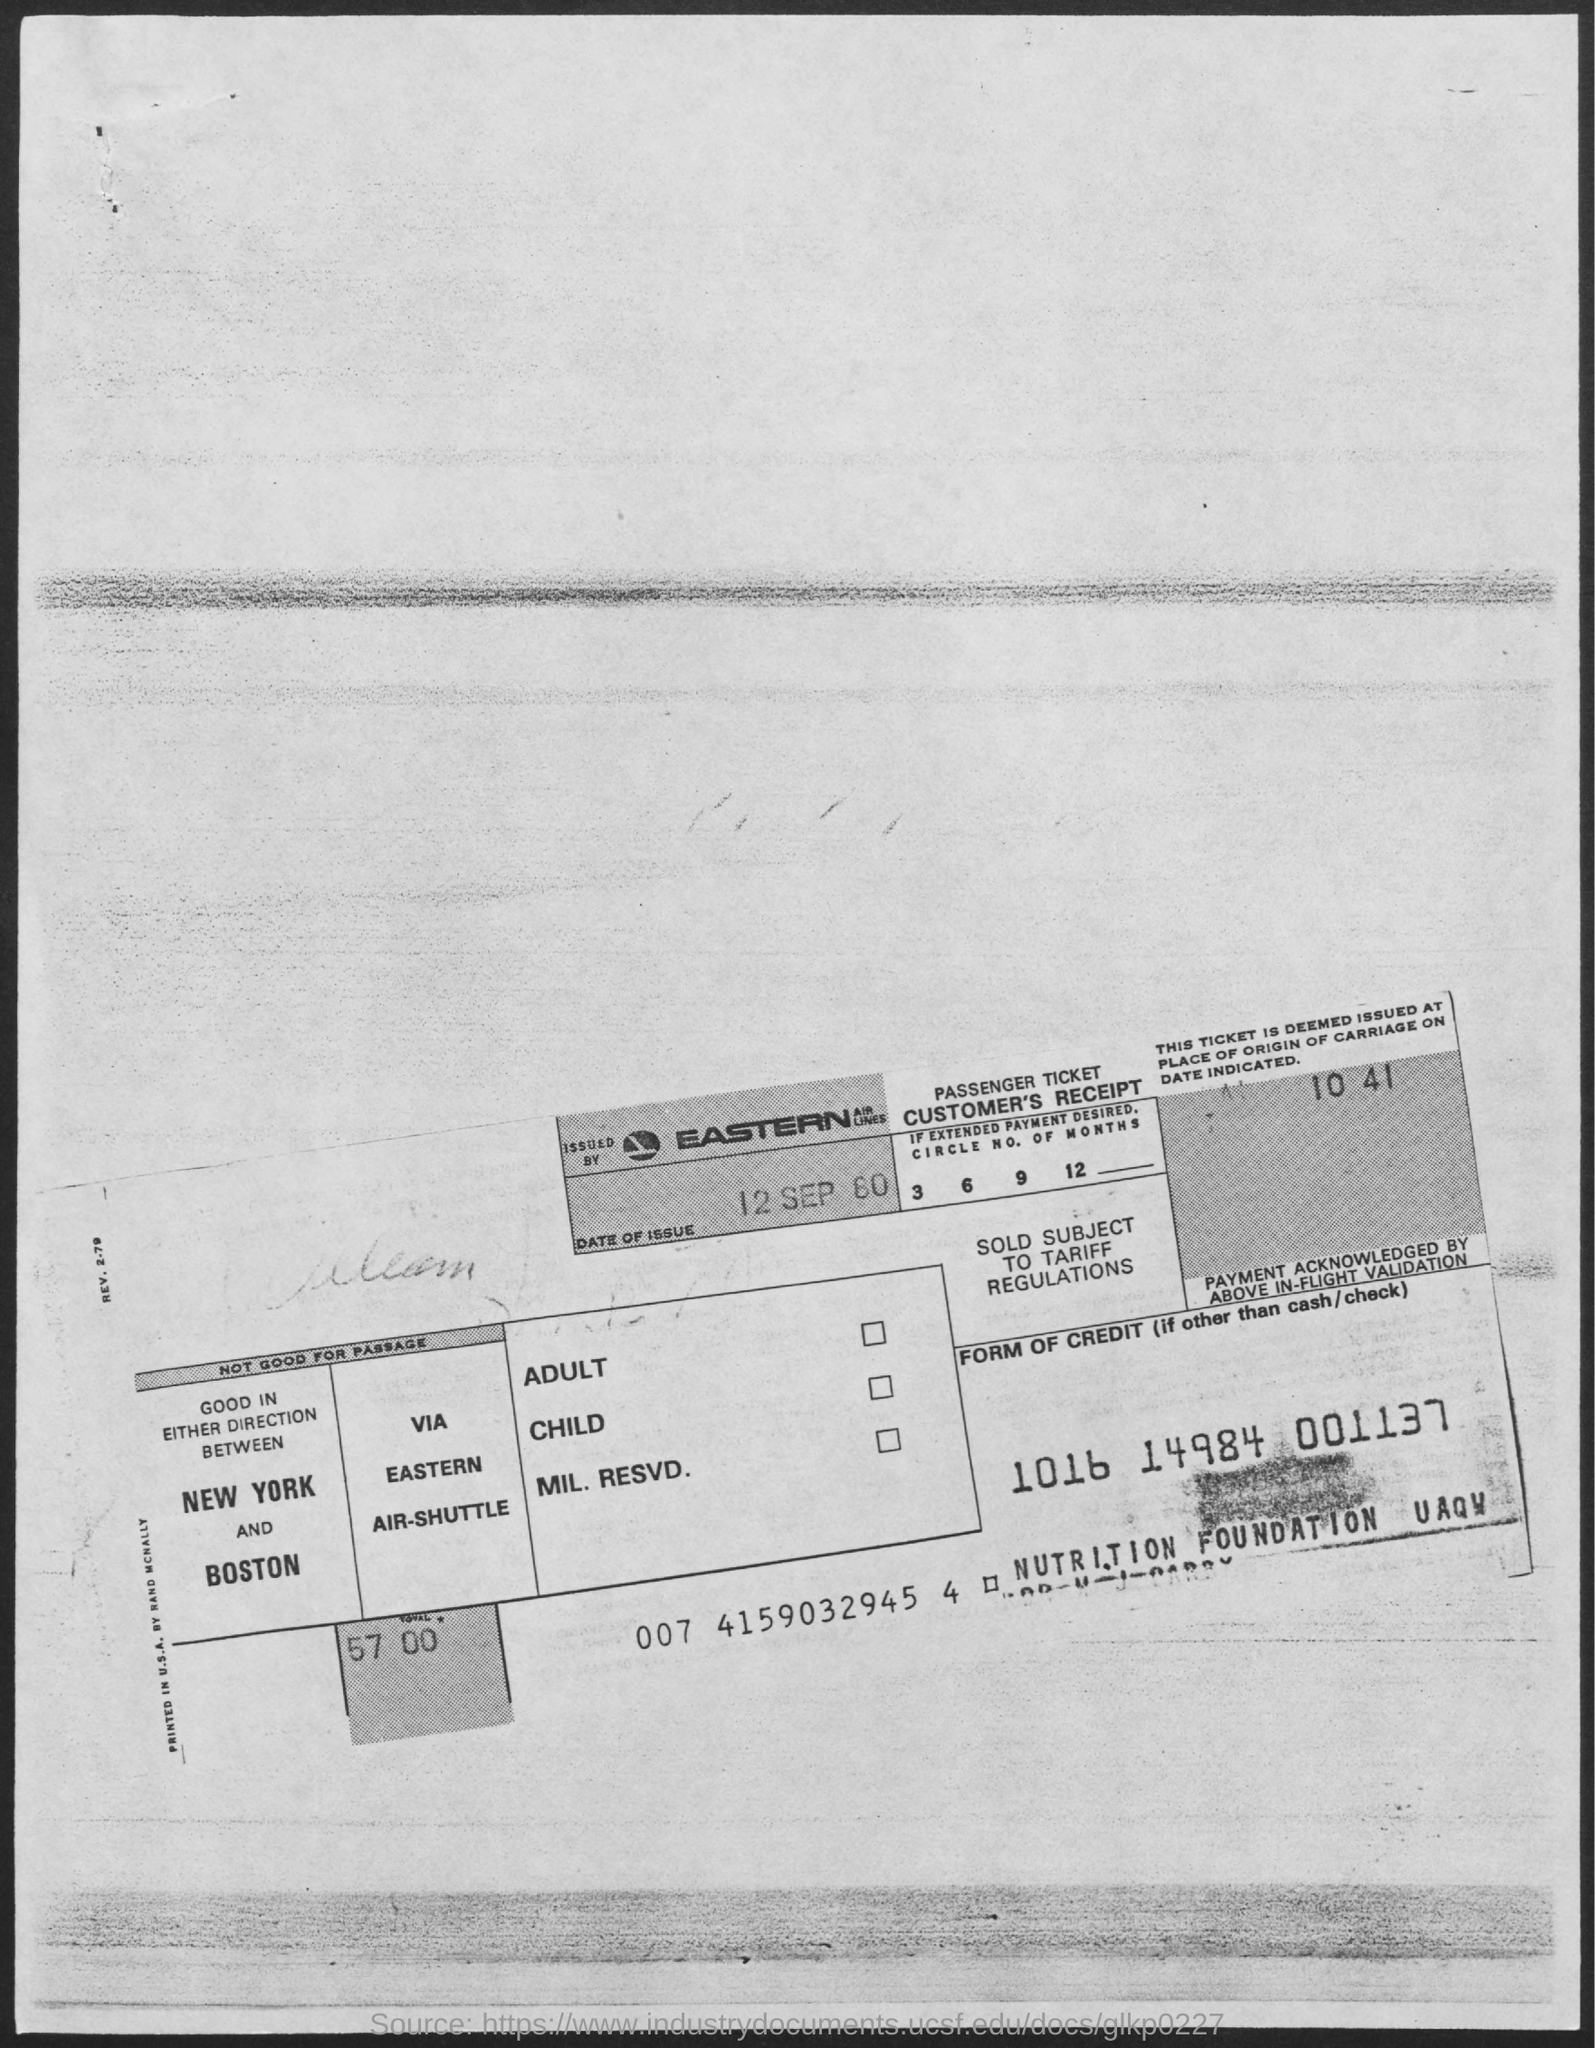The ticket is issued by which airlines?
Offer a very short reply. Eastern Airlines. What is the total amount?
Give a very brief answer. 57. 